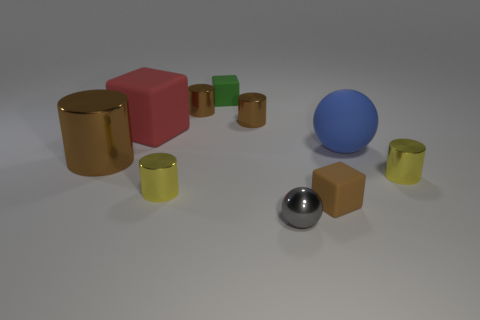There is a large matte sphere; are there any objects right of it?
Offer a very short reply. Yes. The tiny shiny thing that is in front of the tiny matte cube in front of the large shiny object is what shape?
Your response must be concise. Sphere. Is the number of small blocks that are right of the green cube less than the number of matte objects that are in front of the red rubber thing?
Offer a very short reply. Yes. What color is the big matte object that is the same shape as the gray shiny thing?
Offer a very short reply. Blue. How many objects are right of the tiny gray thing and in front of the large brown shiny object?
Provide a short and direct response. 2. Are there more big objects on the right side of the large brown object than small brown things that are behind the big red block?
Offer a terse response. No. How big is the blue thing?
Your answer should be compact. Large. Are there any other red things that have the same shape as the large red rubber object?
Your answer should be very brief. No. There is a tiny gray shiny thing; is it the same shape as the small matte object in front of the green block?
Give a very brief answer. No. What size is the brown object that is in front of the large sphere and behind the tiny brown block?
Offer a terse response. Large. 